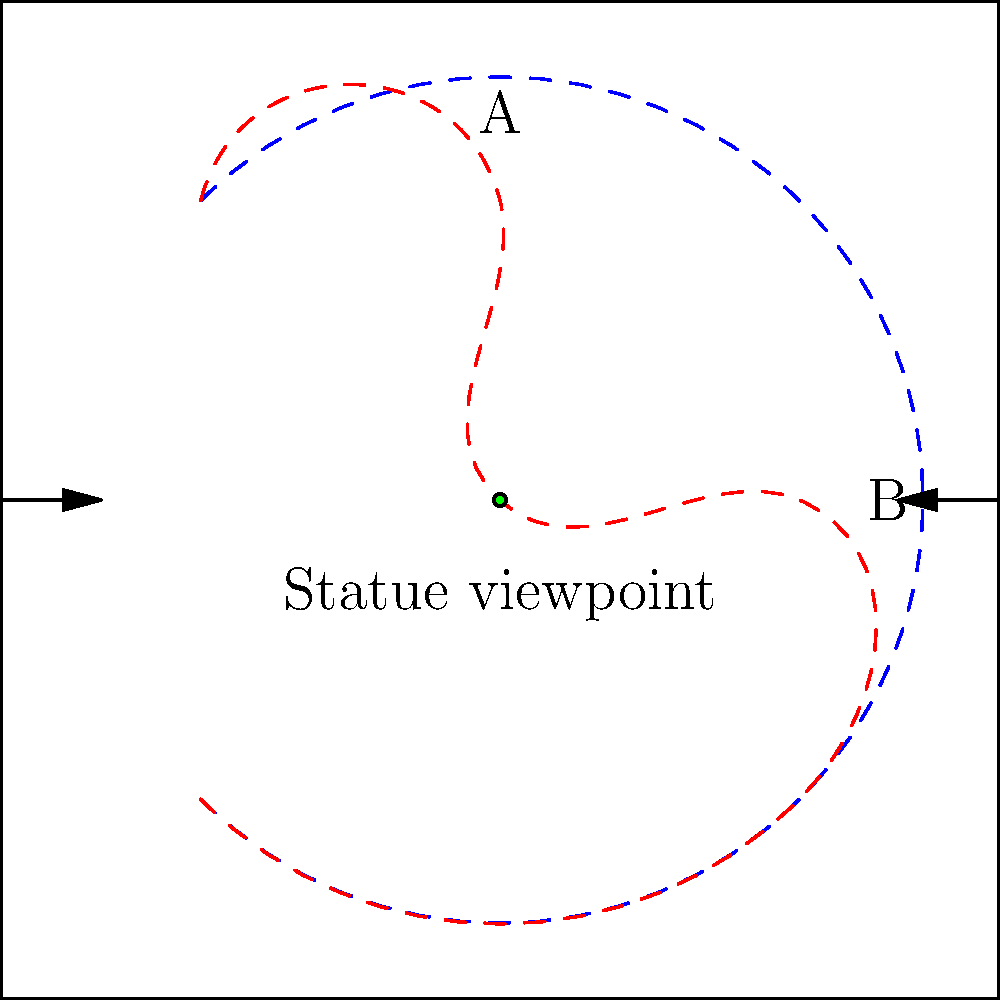Based on the floor plan diagram of the Statue of Liberty visitor area, which queue layout (A or B) would you recommend for optimal visitor flow and experience? Consider factors such as space utilization, visitor comfort, and the ability to view the statue while waiting. To determine the optimal queue layout, we need to consider several factors:

1. Space utilization:
   - Layout A (blue) uses a simple S-shaped pattern
   - Layout B (red) uses a more complex pattern with additional turns

2. Queue length:
   - Layout A appears to have a longer overall queue length
   - Layout B maximizes the available space, potentially accommodating more visitors

3. Visitor comfort:
   - Layout A has fewer turns, which may be more comfortable for visitors
   - Layout B has more turns but allows for better space distribution

4. Statue viewpoint:
   - Layout B passes closer to the statue viewpoint (green dot), allowing more visitors to see the statue while waiting

5. Flow management:
   - Layout B provides more opportunities for staff to manage and direct the flow of visitors

6. Flexibility:
   - Layout B offers more flexibility to adjust queue length based on crowd size

Considering these factors, Layout B (red) is the optimal choice because:
- It maximizes space utilization
- Allows more visitors to view the statue while waiting
- Provides better flow management opportunities
- Offers more flexibility for crowd size variations

While Layout A is simpler, Layout B's benefits outweigh the slight increase in complexity, making it the better option for overall visitor experience and queue management.
Answer: Layout B (red) 